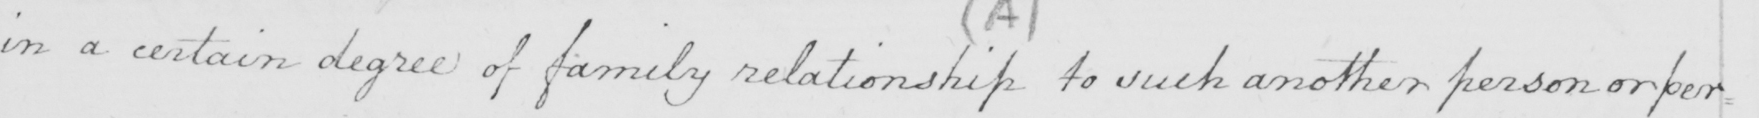Transcribe the text shown in this historical manuscript line. in a certain degree of family relationship to such another person or per= 